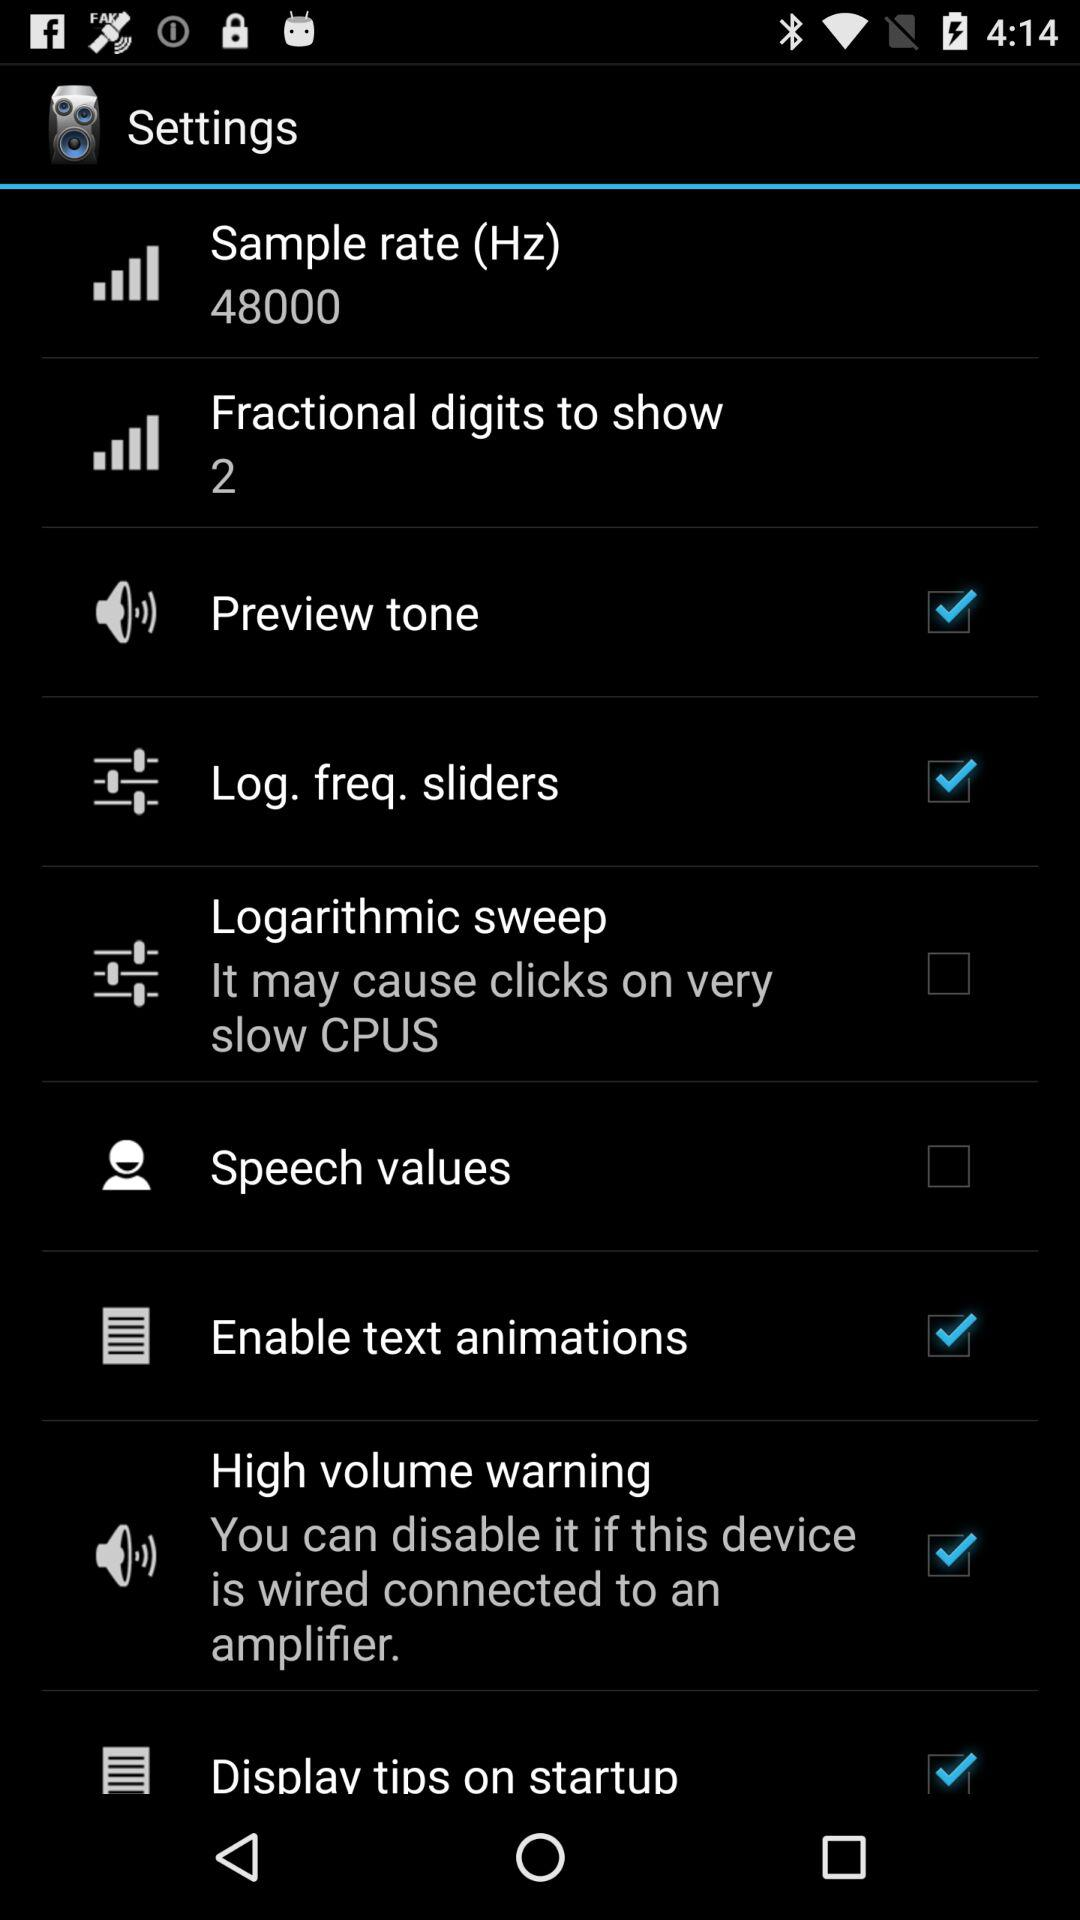What is the sample rate? The sample rate is 48000 Hz. 